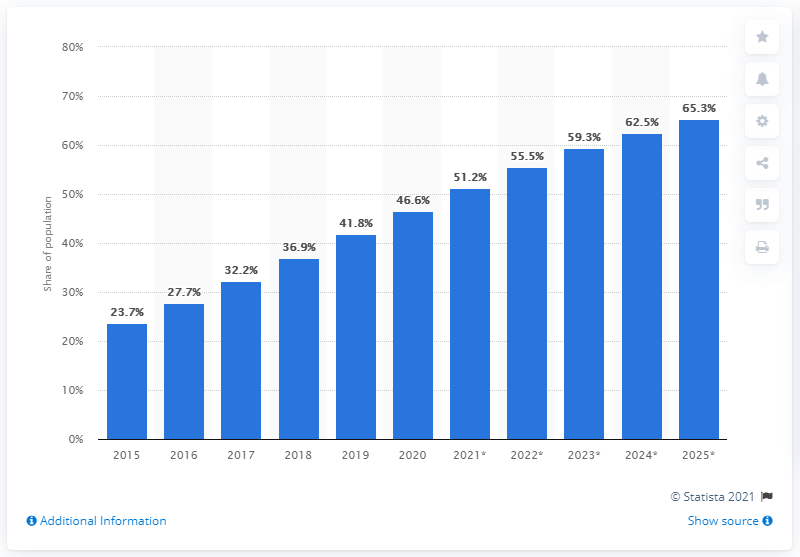Point out several critical features in this image. It is expected that by 2025, 65.3% of Nigeria's population will be using the internet. 